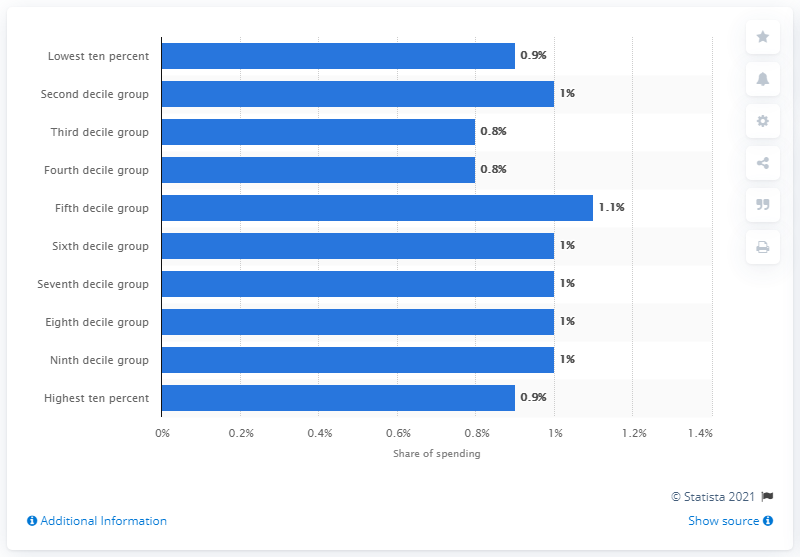Indicate a few pertinent items in this graphic. In 2020, a small percentage of household expenditure in the third and fourth disposable income groups was spent on take-away meals. Specifically, 0.8% of household expenditure in these groups went towards take-away meals. 